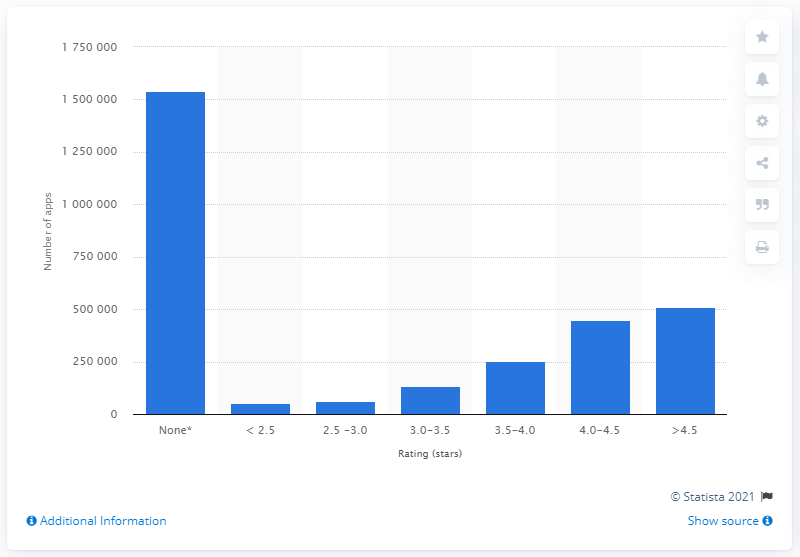Indicate a few pertinent items in this graphic. As of my knowledge cutoff date, there were approximately 15,387,400 apps in the Google Play store with less than three user ratings. 